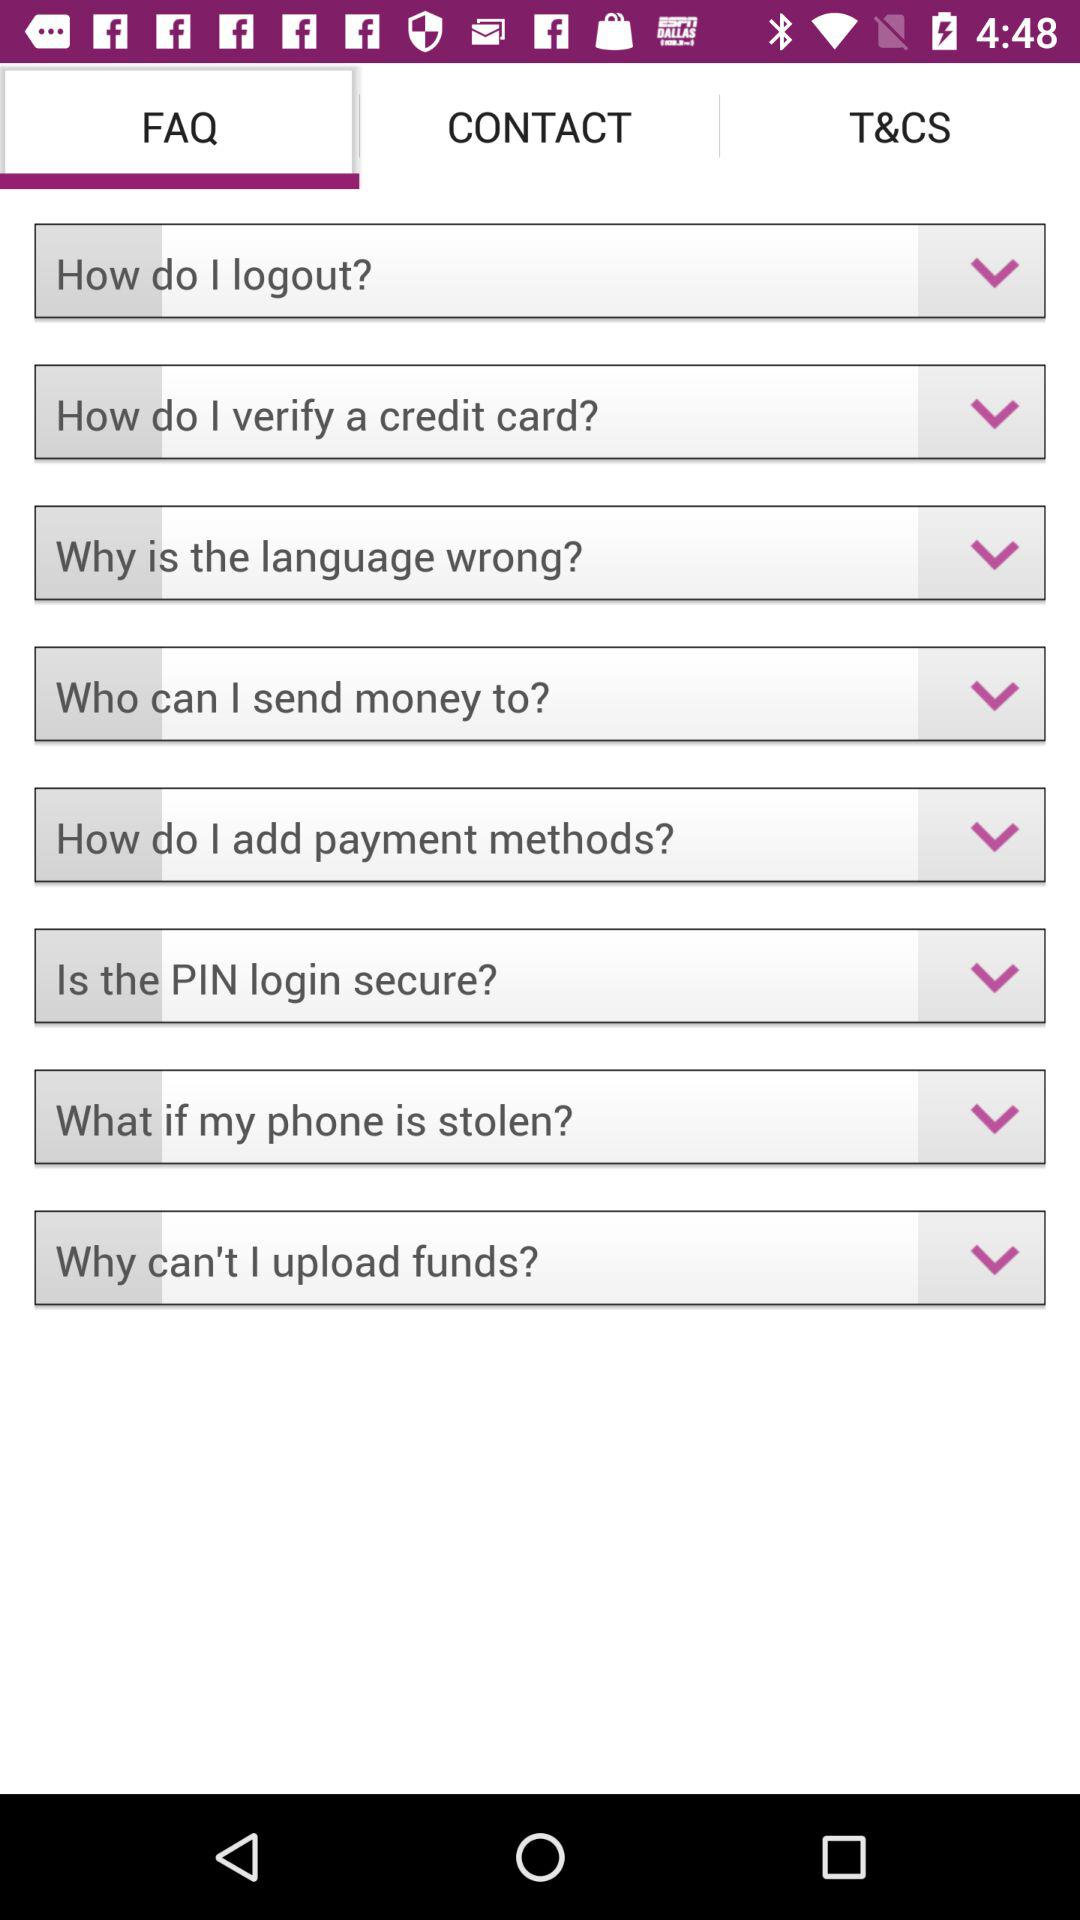How many FAQ items are there in total?
Answer the question using a single word or phrase. 8 